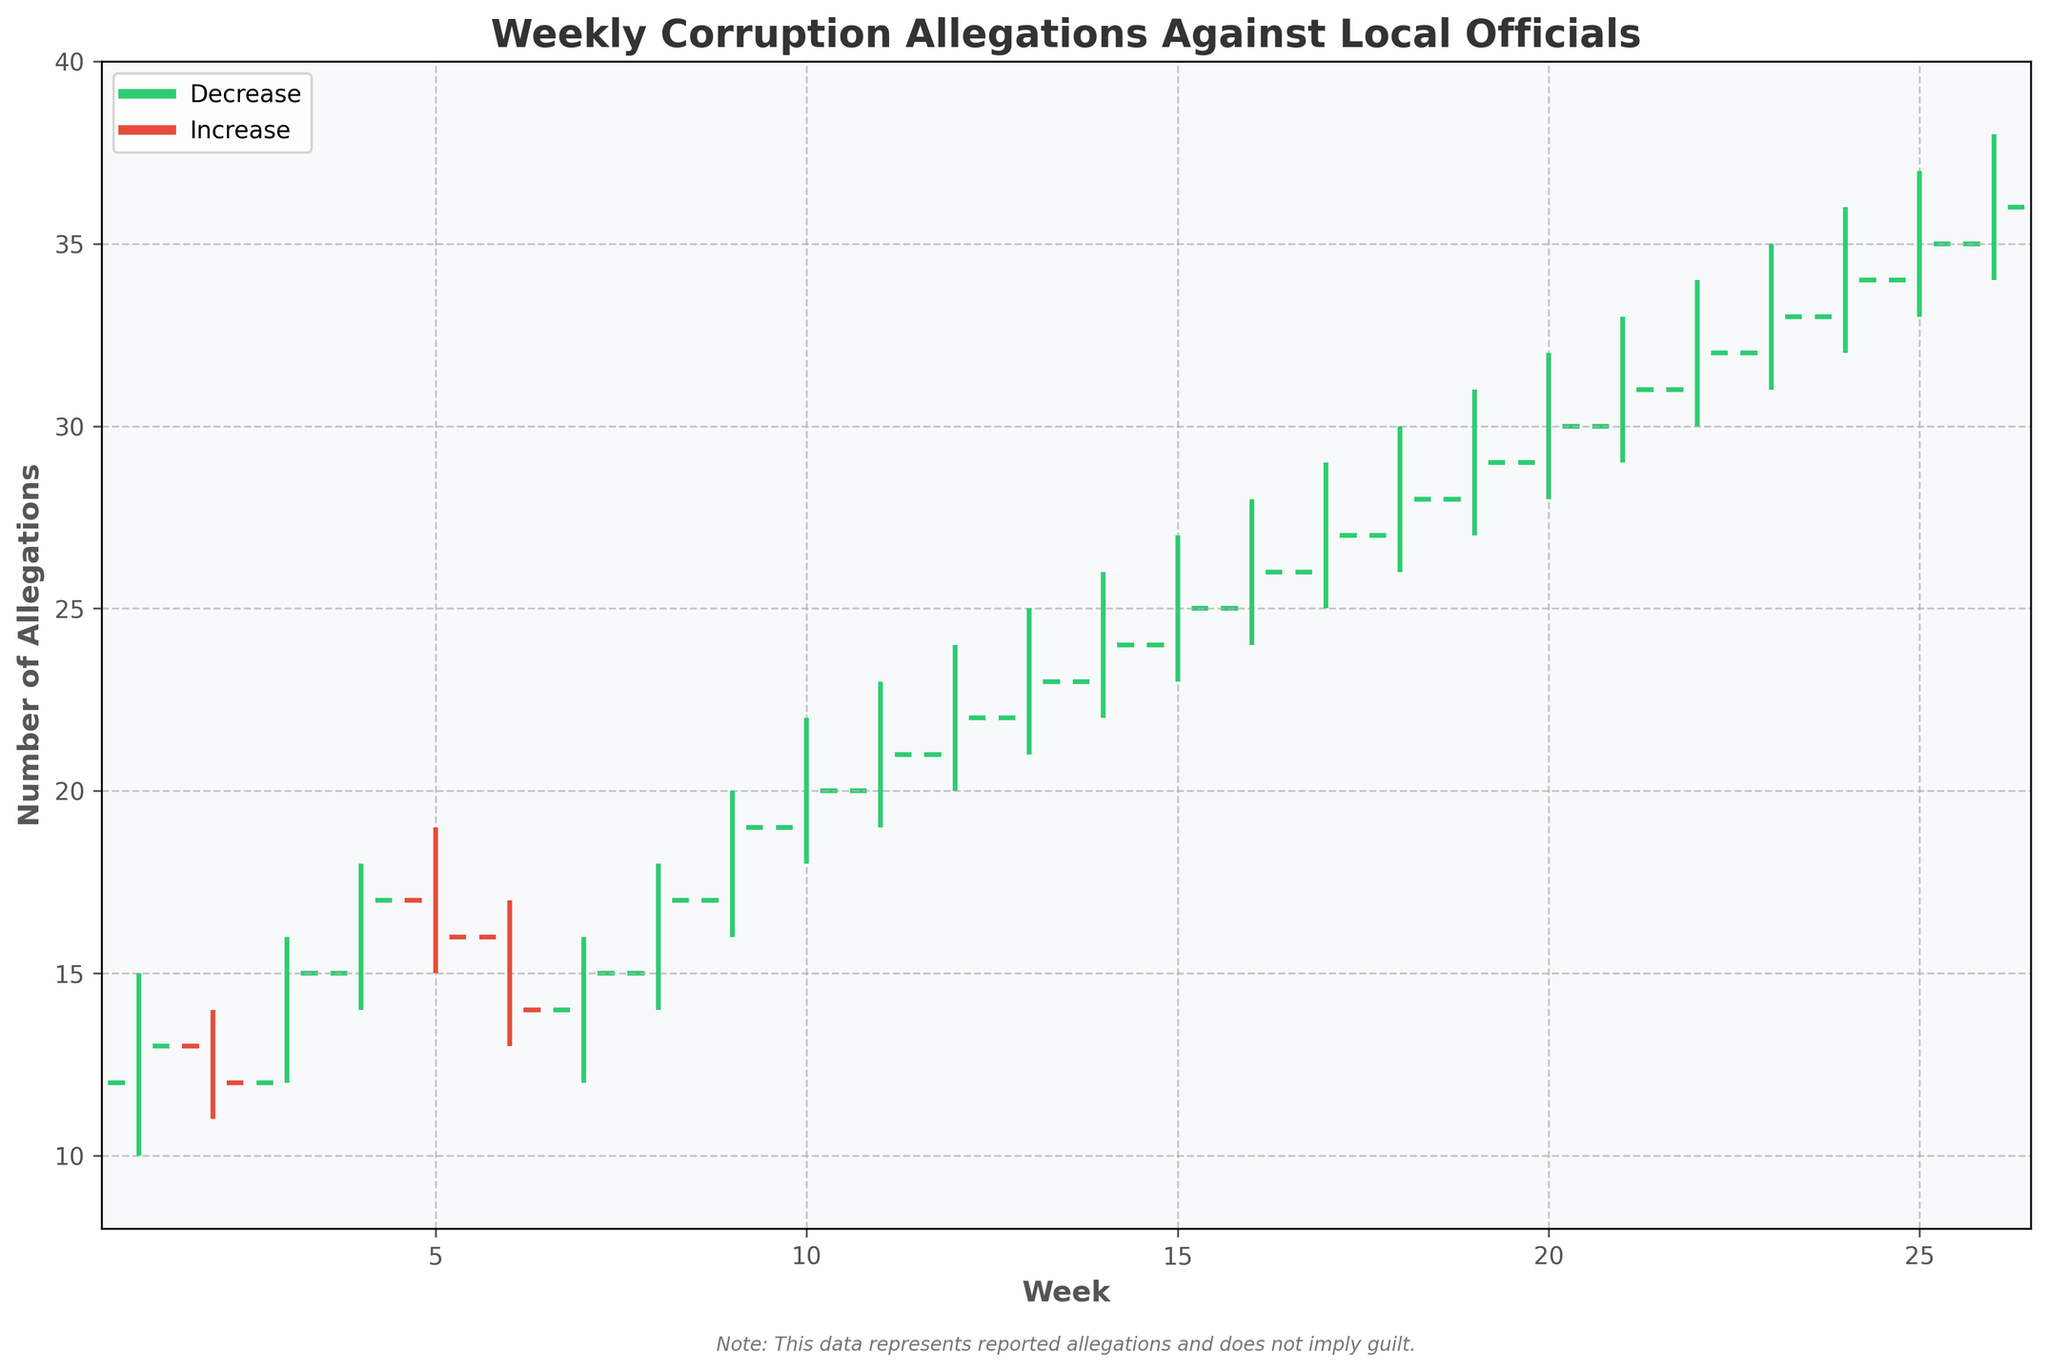How many weeks are represented in the figure? Count the number of distinct weeks on the x-axis, which range from Week 1 to Week 26.
Answer: 26 What is the highest number of allegations reported in a single week? Look for the highest value in the 'High' column, which is represented by the tallest s in the week. The highest vertical line reaches 38.
Answer: 38 During which week did allegations close at the highest value, and what was that value? Locate the highest 'Close' value on the y-axis and find its corresponding week number, which is in Week 26. The highest closing value is 36.
Answer: Week 26, 36 Which week had the greatest range of reported allegations (difference between high and low)? Calculate the range for each week (High - Low) and identify the week with the maximum range: Week 3 has a range of 4 (16-12), and Week 10 has a range of 4 (22-18). Week 10 also has a range of 4. Select the highest range.
Answer: Week 10 Does the figure show more weeks with allegations increasing or decreasing? Count the number of increases (green lines) and decreases (red lines). There are more green lines (increase) than red lines (decrease).
Answer: Increasing What trend can be observed over the year in the number of allegations reported? Observe the general direction of the closing values over the weeks. There is a steadily increasing trend.
Answer: Increasing Between weeks 10 and 20, which week had the highest closing value? Compare the closing values from Week 10 to Week 20 and find the maximum closing value, which is at Week 20 with a close of 30.
Answer: Week 20 What is the median closing value for all weeks? List all closing values, sort them, and find the median. For 26 data points, the median is the average of the 13th and 14th values. The 13th value is 23 and the 14th value is 24, so (23+24)/2 = 23.5.
Answer: 23.5 Which weeks saw the maximum increase in allegations from open to close? Calculate the difference between the 'Open' and 'Close' for each week and identify the maximum increase: Week 18 saw the maximum increase of 1 (from 27 to 28).
Answer: Week 18 